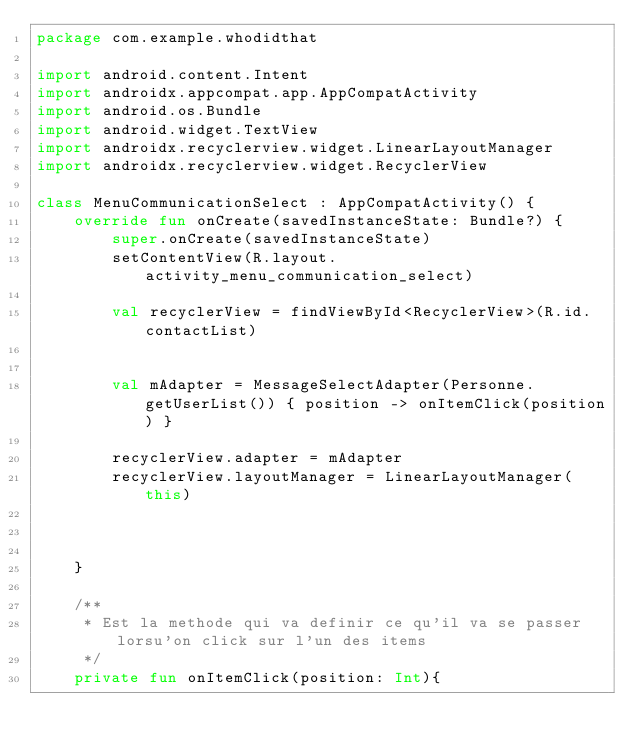Convert code to text. <code><loc_0><loc_0><loc_500><loc_500><_Kotlin_>package com.example.whodidthat

import android.content.Intent
import androidx.appcompat.app.AppCompatActivity
import android.os.Bundle
import android.widget.TextView
import androidx.recyclerview.widget.LinearLayoutManager
import androidx.recyclerview.widget.RecyclerView

class MenuCommunicationSelect : AppCompatActivity() {
    override fun onCreate(savedInstanceState: Bundle?) {
        super.onCreate(savedInstanceState)
        setContentView(R.layout.activity_menu_communication_select)

        val recyclerView = findViewById<RecyclerView>(R.id.contactList)


        val mAdapter = MessageSelectAdapter(Personne.getUserList()) { position -> onItemClick(position) }

        recyclerView.adapter = mAdapter
        recyclerView.layoutManager = LinearLayoutManager(this)



    }

    /**
     * Est la methode qui va definir ce qu'il va se passer lorsu'on click sur l'un des items
     */
    private fun onItemClick(position: Int){</code> 